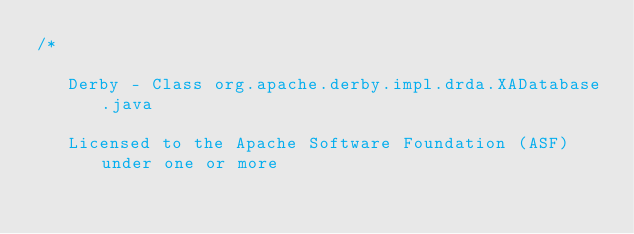<code> <loc_0><loc_0><loc_500><loc_500><_Java_>/*

   Derby - Class org.apache.derby.impl.drda.XADatabase.java

   Licensed to the Apache Software Foundation (ASF) under one or more</code> 